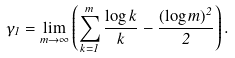Convert formula to latex. <formula><loc_0><loc_0><loc_500><loc_500>\gamma _ { 1 } = \lim _ { m \to \infty } \left ( \sum _ { k = 1 } ^ { m } \frac { \log k } { k } - \frac { ( \log m ) ^ { 2 } } { 2 } \right ) .</formula> 